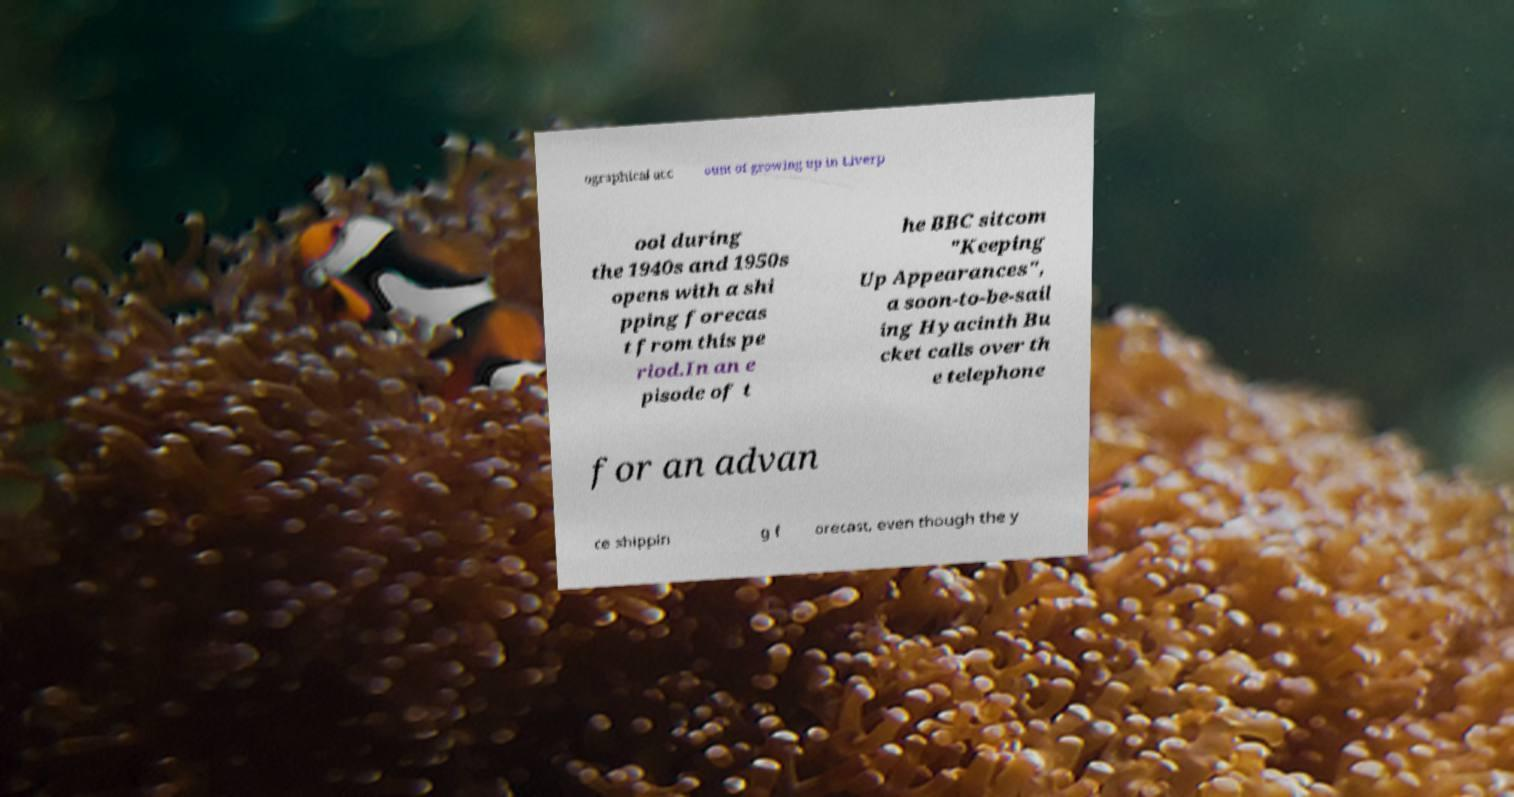Could you assist in decoding the text presented in this image and type it out clearly? ographical acc ount of growing up in Liverp ool during the 1940s and 1950s opens with a shi pping forecas t from this pe riod.In an e pisode of t he BBC sitcom "Keeping Up Appearances", a soon-to-be-sail ing Hyacinth Bu cket calls over th e telephone for an advan ce shippin g f orecast, even though the y 